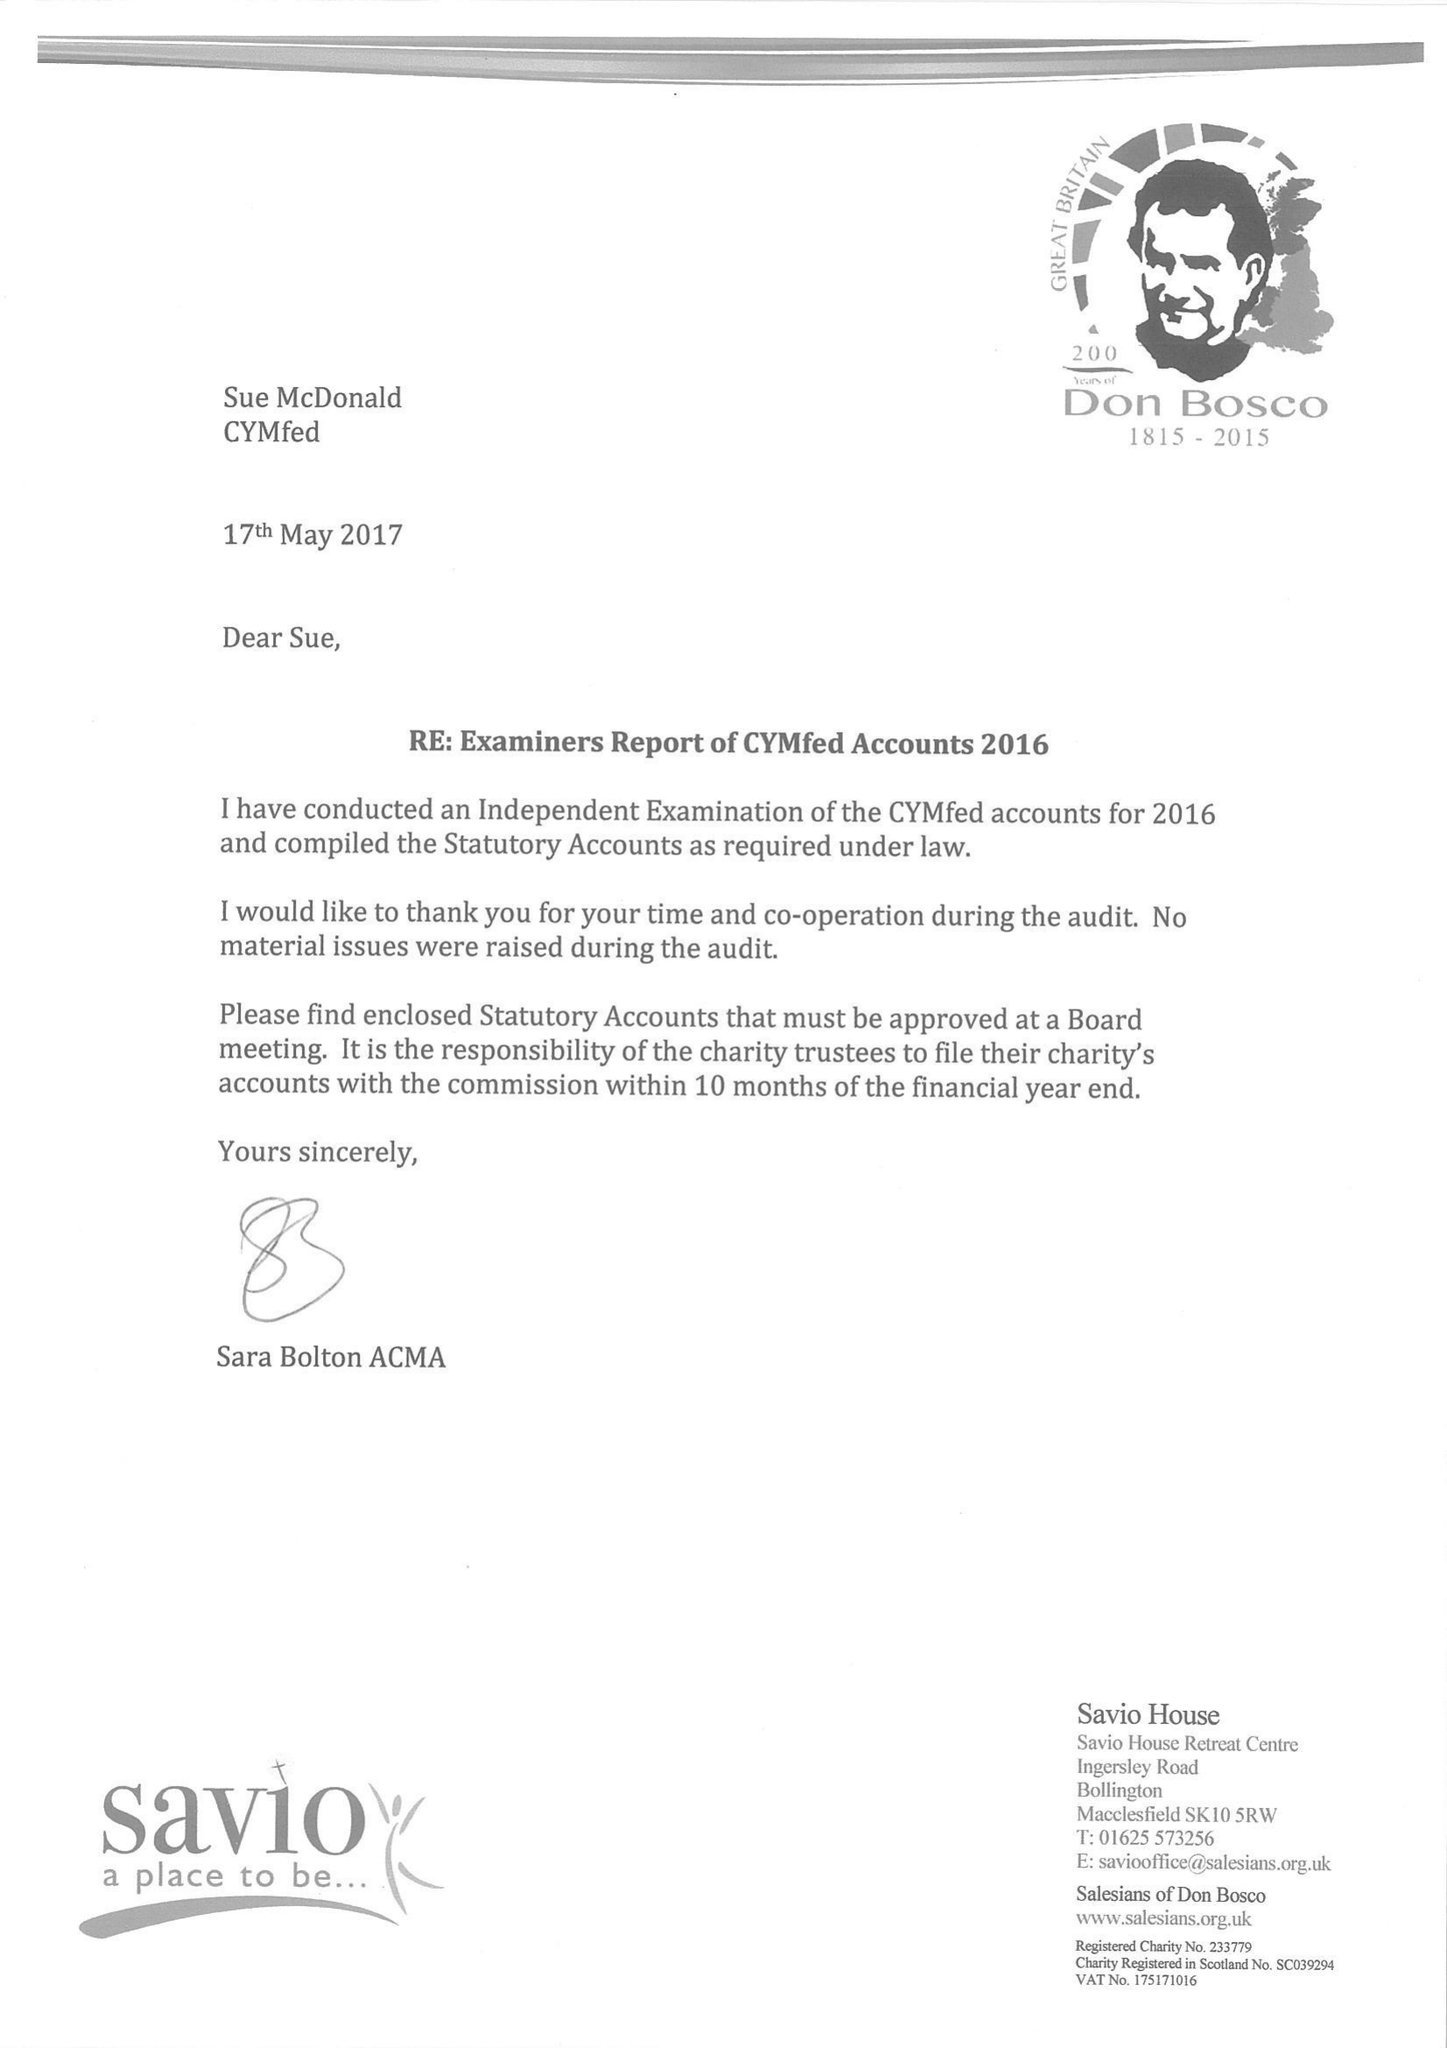What is the value for the charity_name?
Answer the question using a single word or phrase. Cymfed 